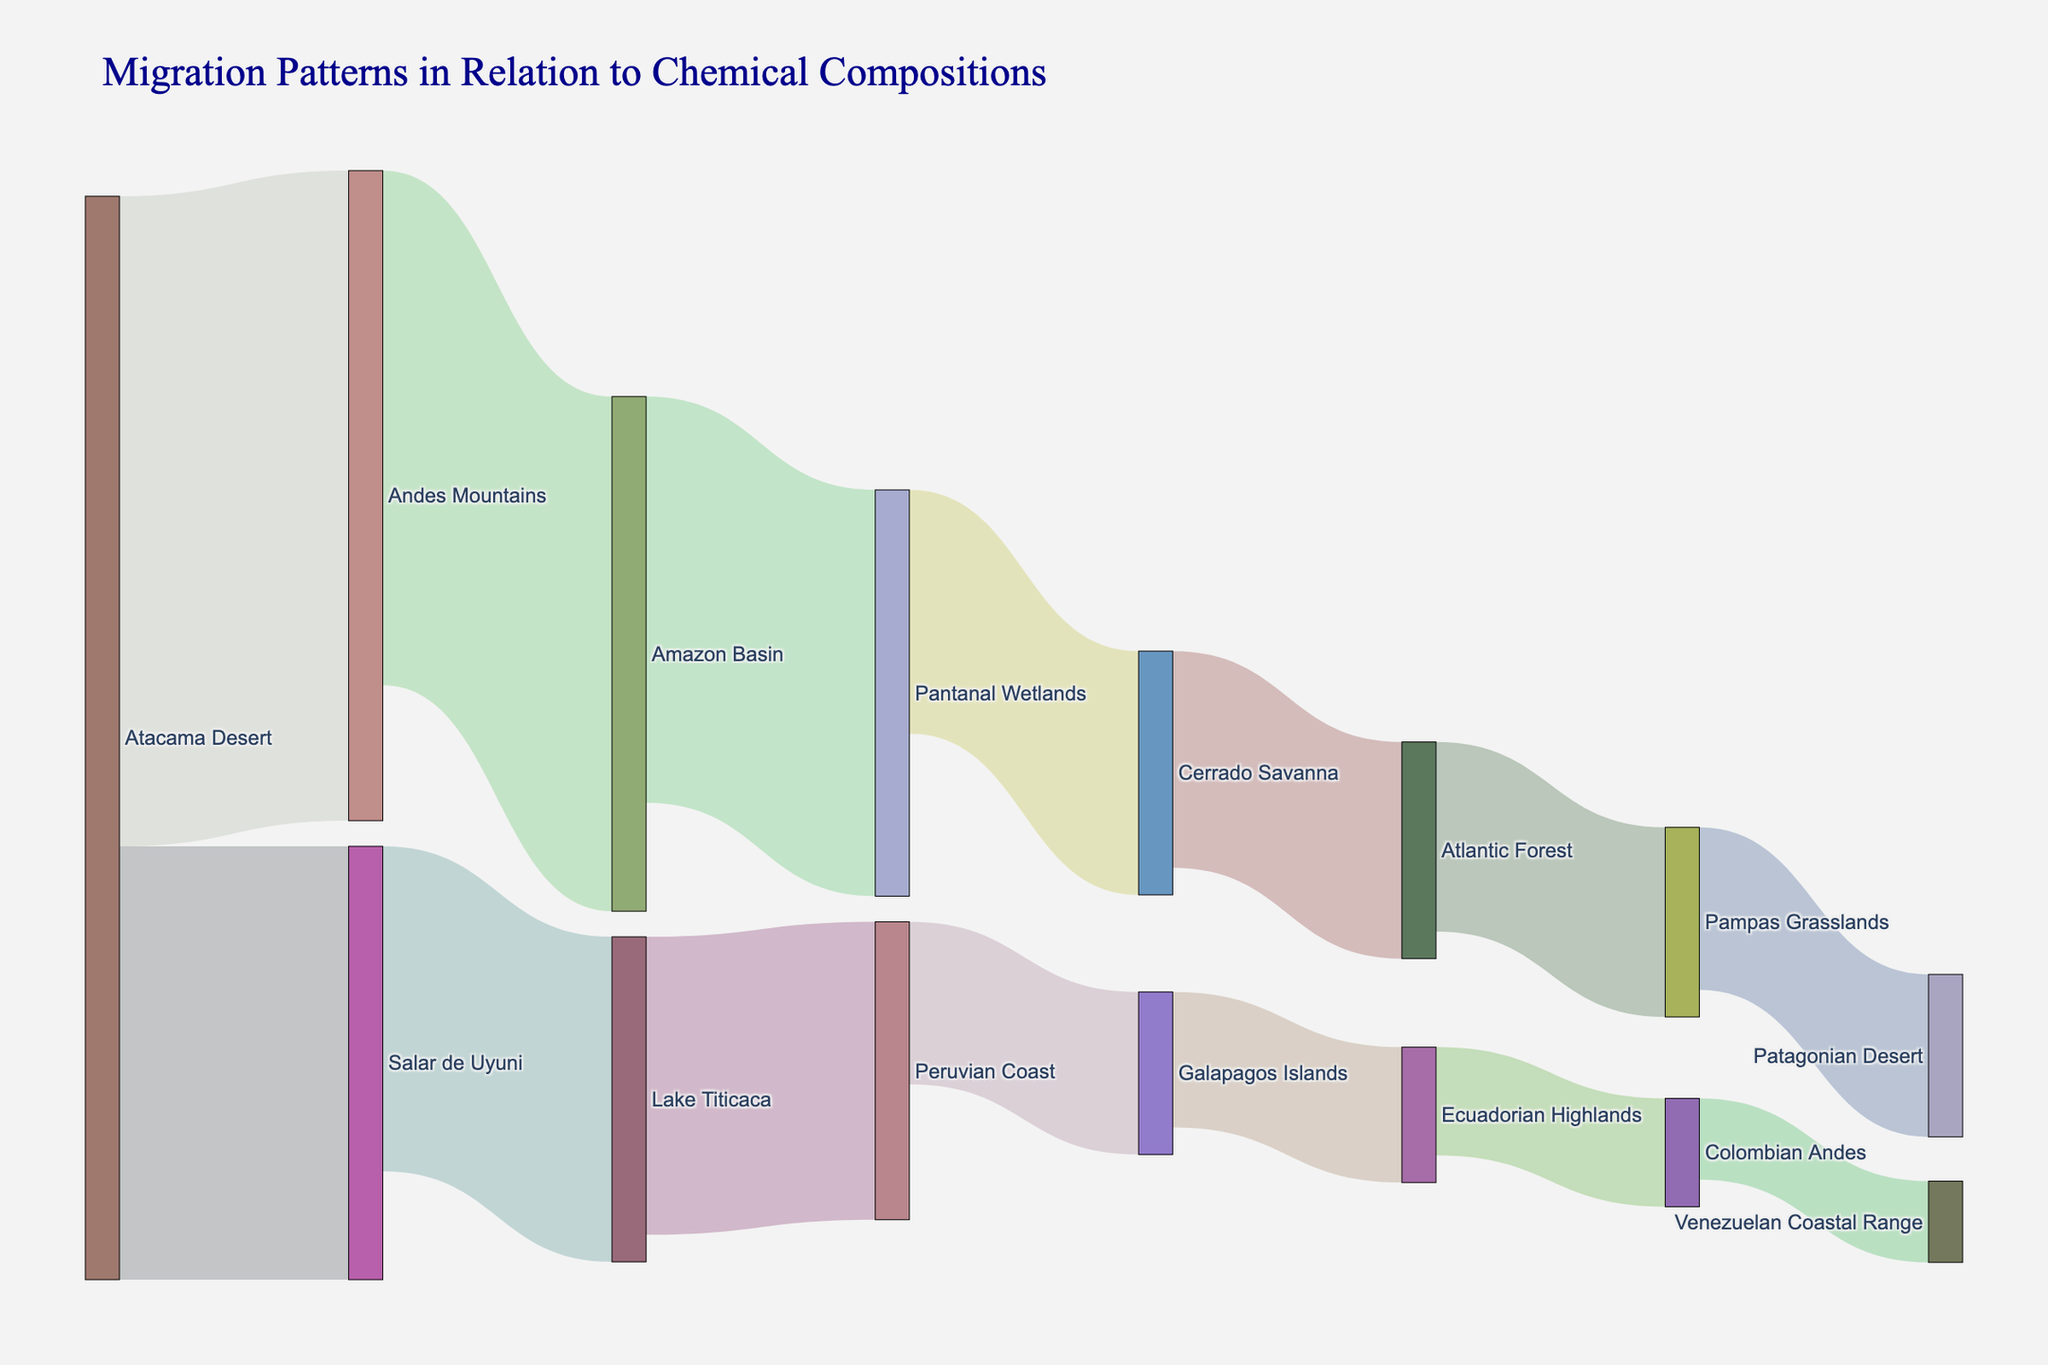What is the initial migration flow with the highest value? Identify the source-target pair with the largest value; here, it is Atacama Desert to Andes Mountains with a value of 1200.
Answer: Atacama Desert to Andes Mountains Which migration flow connects to the Atlantic Forest? Look at the link where the target is the Atlantic Forest; the connection is from Cerrado Savanna.
Answer: Cerrado Savanna What is the total migration value from Atacama Desert to all destinations? Sum the values of all flows originating from Atacama Desert: 1200 (Andes Mountains) + 800 (Salar de Uyuni) = 2000.
Answer: 2000 Is the migration flow from Lake Titicaca to Peruvian Coast greater than from Pantanal Wetlands to Cerrado Savanna? Compare the values: Lake Titicaca to Peruvian Coast is 550 versus Pantanal Wetlands to Cerrado Savanna, which is 450.
Answer: Yes What is the smallest recorded migration value in the figure? Identify the flow with the smallest value by comparing all the values listed; the smallest is from Colombian Andes to Venezuelan Coastal Range with a value of 150.
Answer: 150 How many unique migration routes are shown in the diagram? Count the number of links (pairs of migrations from source to target) shown in the diagram; there are 14 routes.
Answer: 14 From which location does the largest number of migrations originate? Identify the source with the highest number of distinct target locations; Atacama Desert has 2 routes, more than any single other location.
Answer: Atacama Desert Calculate the average value of migration flows connected to the Andes Mountains (both incoming and outgoing). Sum of values: 1200 (incoming from Atacama Desert) + 950 (outgoing to Amazon Basin) = 2150. There are 2 flows, so the average is 2150 / 2 = 1075.
Answer: 1075 Which migration route involves the Galapagos Islands and what is its value? Look for the link involving Galapagos Islands; it is from Peruvian Coast to Galapagos Islands with a value of 300.
Answer: From Peruvian Coast to Galapagos Islands, 300 Is the migration value from Pampas Grasslands to Patagonian Desert higher than from Atlantic Forest to Pampas Grasslands? Compare the values: Pampas Grasslands to Patagonian Desert is 300 versus Atlantic Forest to Pampas Grasslands is 350.
Answer: No 